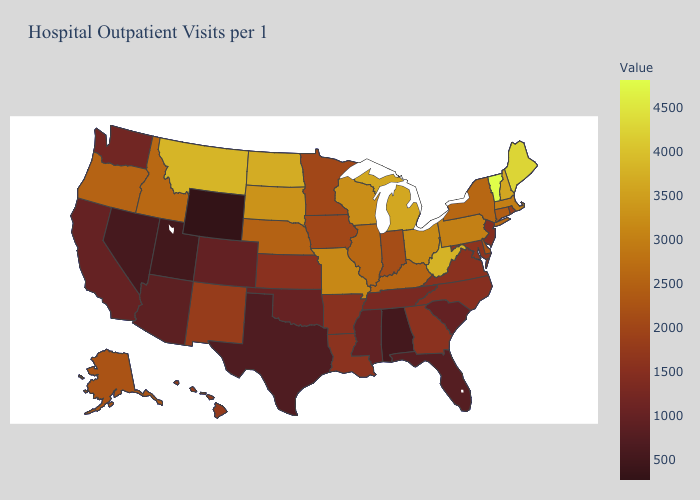Among the states that border Georgia , does Alabama have the lowest value?
Give a very brief answer. Yes. Does Minnesota have the highest value in the USA?
Short answer required. No. Does the map have missing data?
Keep it brief. No. Does the map have missing data?
Be succinct. No. Among the states that border Florida , does Alabama have the highest value?
Short answer required. No. Does Wisconsin have the lowest value in the USA?
Be succinct. No. 